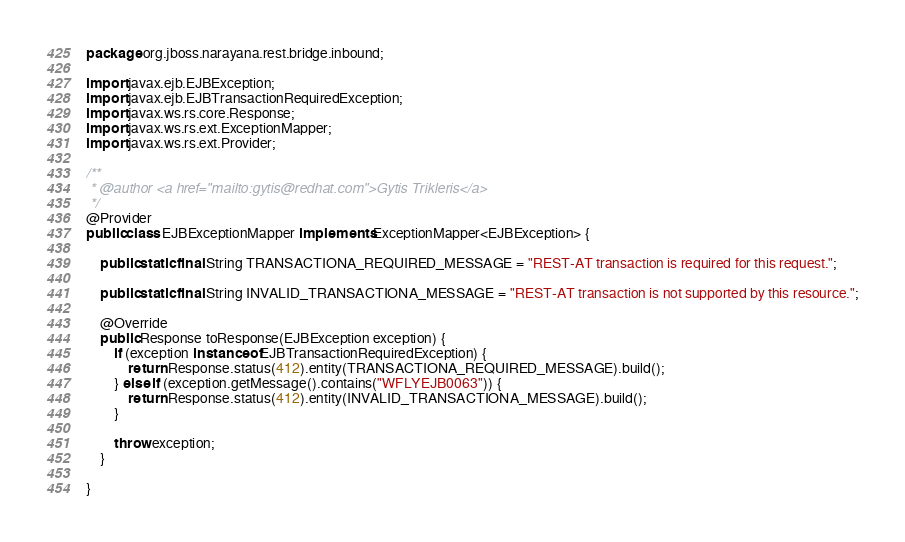<code> <loc_0><loc_0><loc_500><loc_500><_Java_>package org.jboss.narayana.rest.bridge.inbound;

import javax.ejb.EJBException;
import javax.ejb.EJBTransactionRequiredException;
import javax.ws.rs.core.Response;
import javax.ws.rs.ext.ExceptionMapper;
import javax.ws.rs.ext.Provider;

/**
 * @author <a href="mailto:gytis@redhat.com">Gytis Trikleris</a>
 */
@Provider
public class EJBExceptionMapper implements ExceptionMapper<EJBException> {

    public static final String TRANSACTIONA_REQUIRED_MESSAGE = "REST-AT transaction is required for this request.";

    public static final String INVALID_TRANSACTIONA_MESSAGE = "REST-AT transaction is not supported by this resource.";

    @Override
    public Response toResponse(EJBException exception) {
        if (exception instanceof EJBTransactionRequiredException) {
            return Response.status(412).entity(TRANSACTIONA_REQUIRED_MESSAGE).build();
        } else if (exception.getMessage().contains("WFLYEJB0063")) {
            return Response.status(412).entity(INVALID_TRANSACTIONA_MESSAGE).build();
        }

        throw exception;
    }

}
</code> 